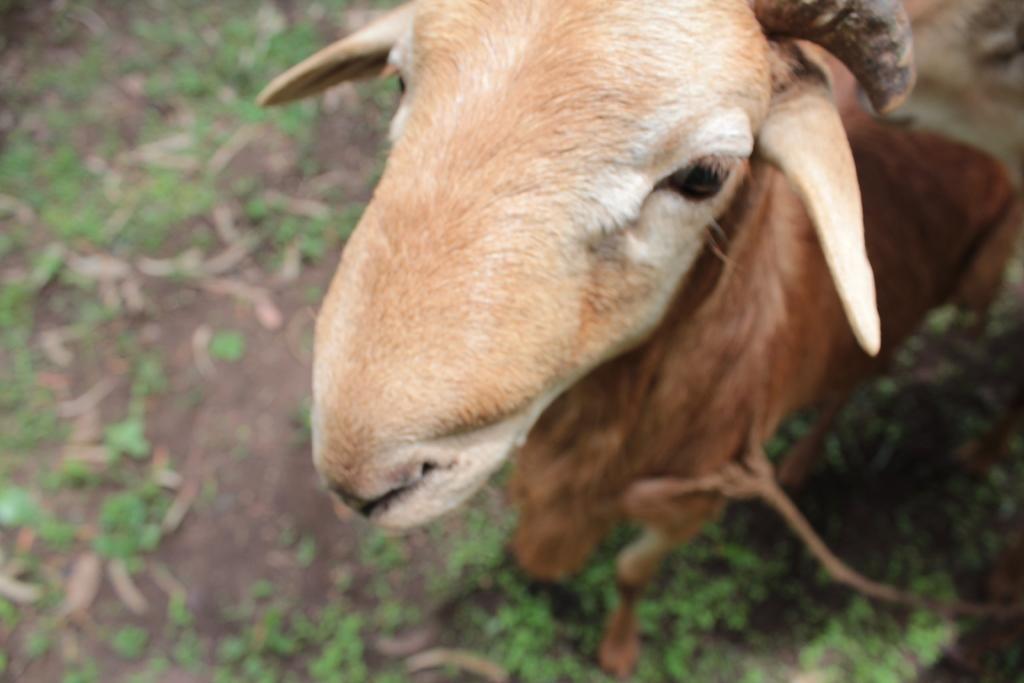Describe this image in one or two sentences. In this image there is one Goat is on right side of this image and there is a floor is on the left side of this image. 